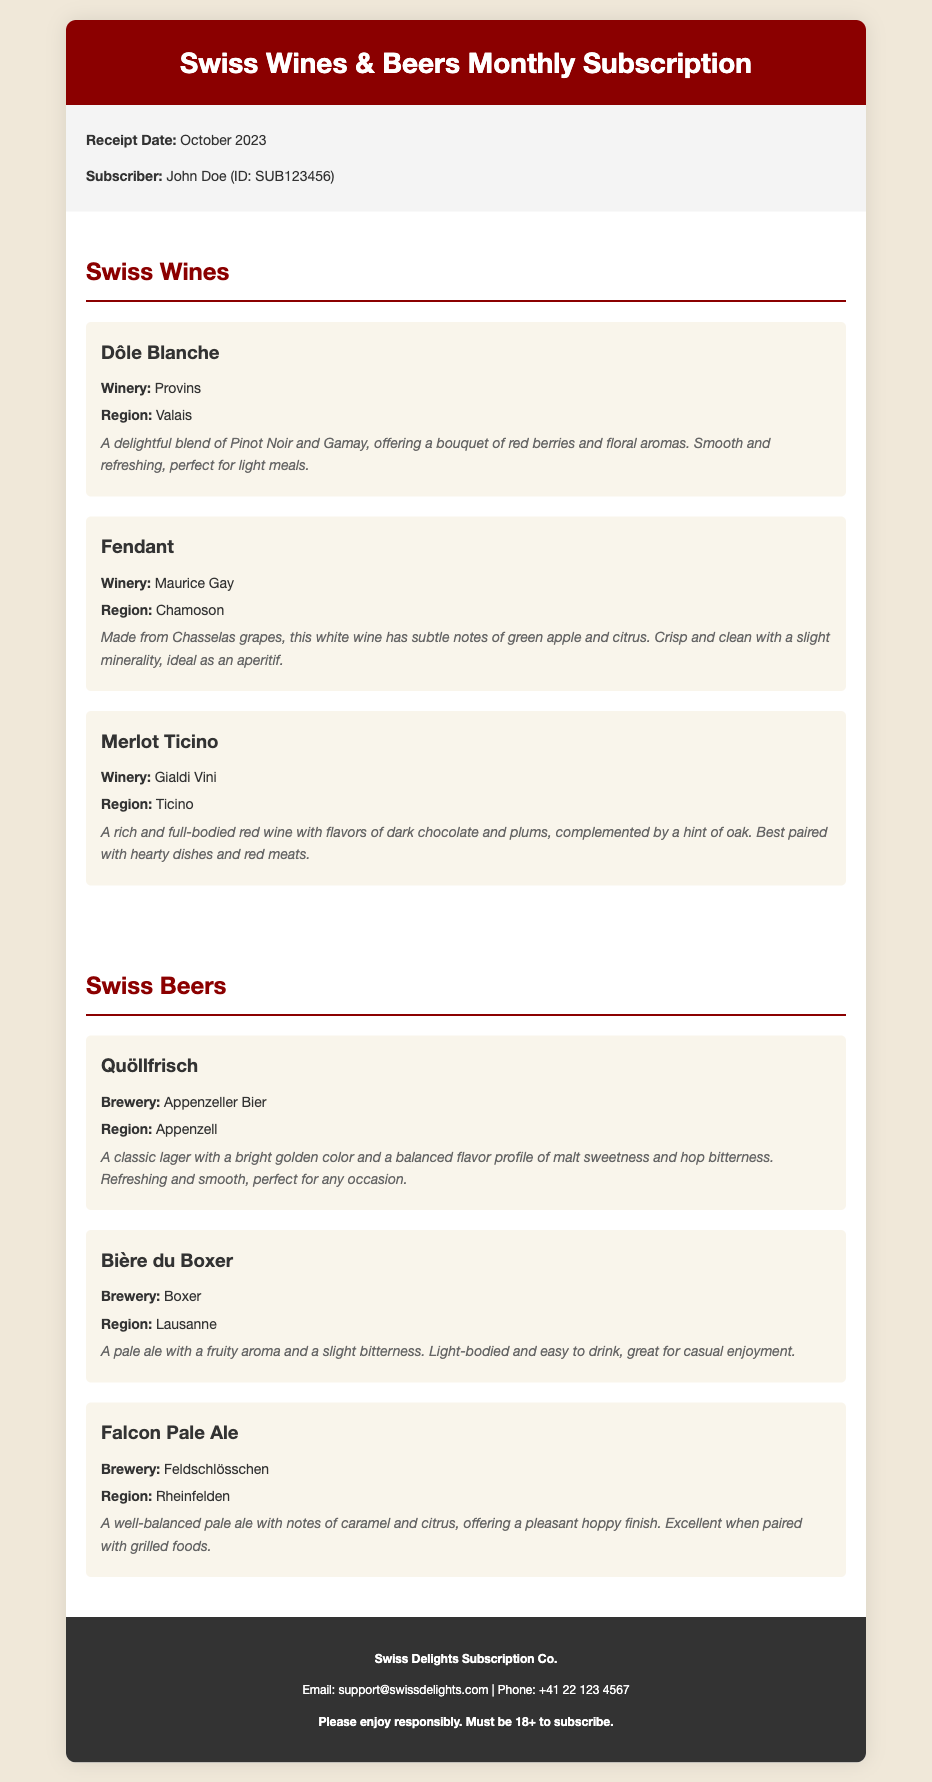What is the receipt date? The document specifies the date when the receipt was issued, which is October 2023.
Answer: October 2023 Who is the subscriber? The document provides the name of the subscriber along with their ID, which is John Doe (ID: SUB123456).
Answer: John Doe What winery produces Dôle Blanche? The winery is mentioned in the section about wines, specifically for Dôle Blanche which is produced by Provins.
Answer: Provins What brewery makes Bière du Boxer? The document indicates that Bière du Boxer is brewed by Boxer, which is listed in the beers section.
Answer: Boxer What tasting notes are associated with Fendant? The document provides a description of Fendant's tasting notes, mentioning subtle notes of green apple and citrus.
Answer: Subtle notes of green apple and citrus Which wine is best paired with hearty dishes? The document suggests that Merlot Ticino, characterized by dark chocolate and plums, is best paired with hearty dishes.
Answer: Merlot Ticino What region is Quöllfrisch from? The brewery's information identifies the origin of Quöllfrisch as Appenzell, which is specified in the document.
Answer: Appenzell How many wines are listed in the subscription? The document counts three wines listed in the Swiss Wines section, which can be directly observed.
Answer: 3 What is the phone number for Swiss Delights Subscription Co.? The footer provides a contact number for the subscription company, which is +41 22 123 4567.
Answer: +41 22 123 4567 